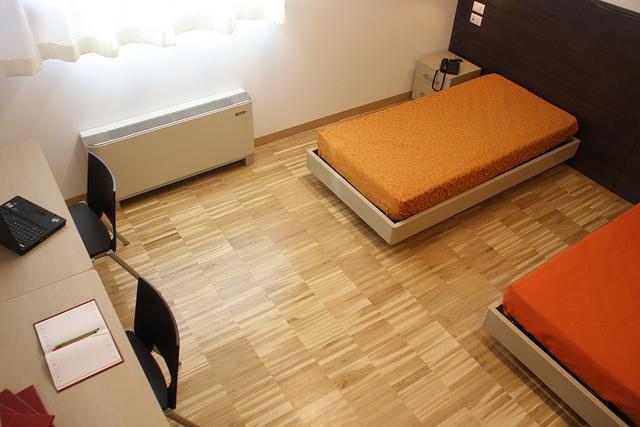How many beds?
Give a very brief answer. 2. How many chairs are there?
Give a very brief answer. 2. How many beds are there?
Give a very brief answer. 2. 